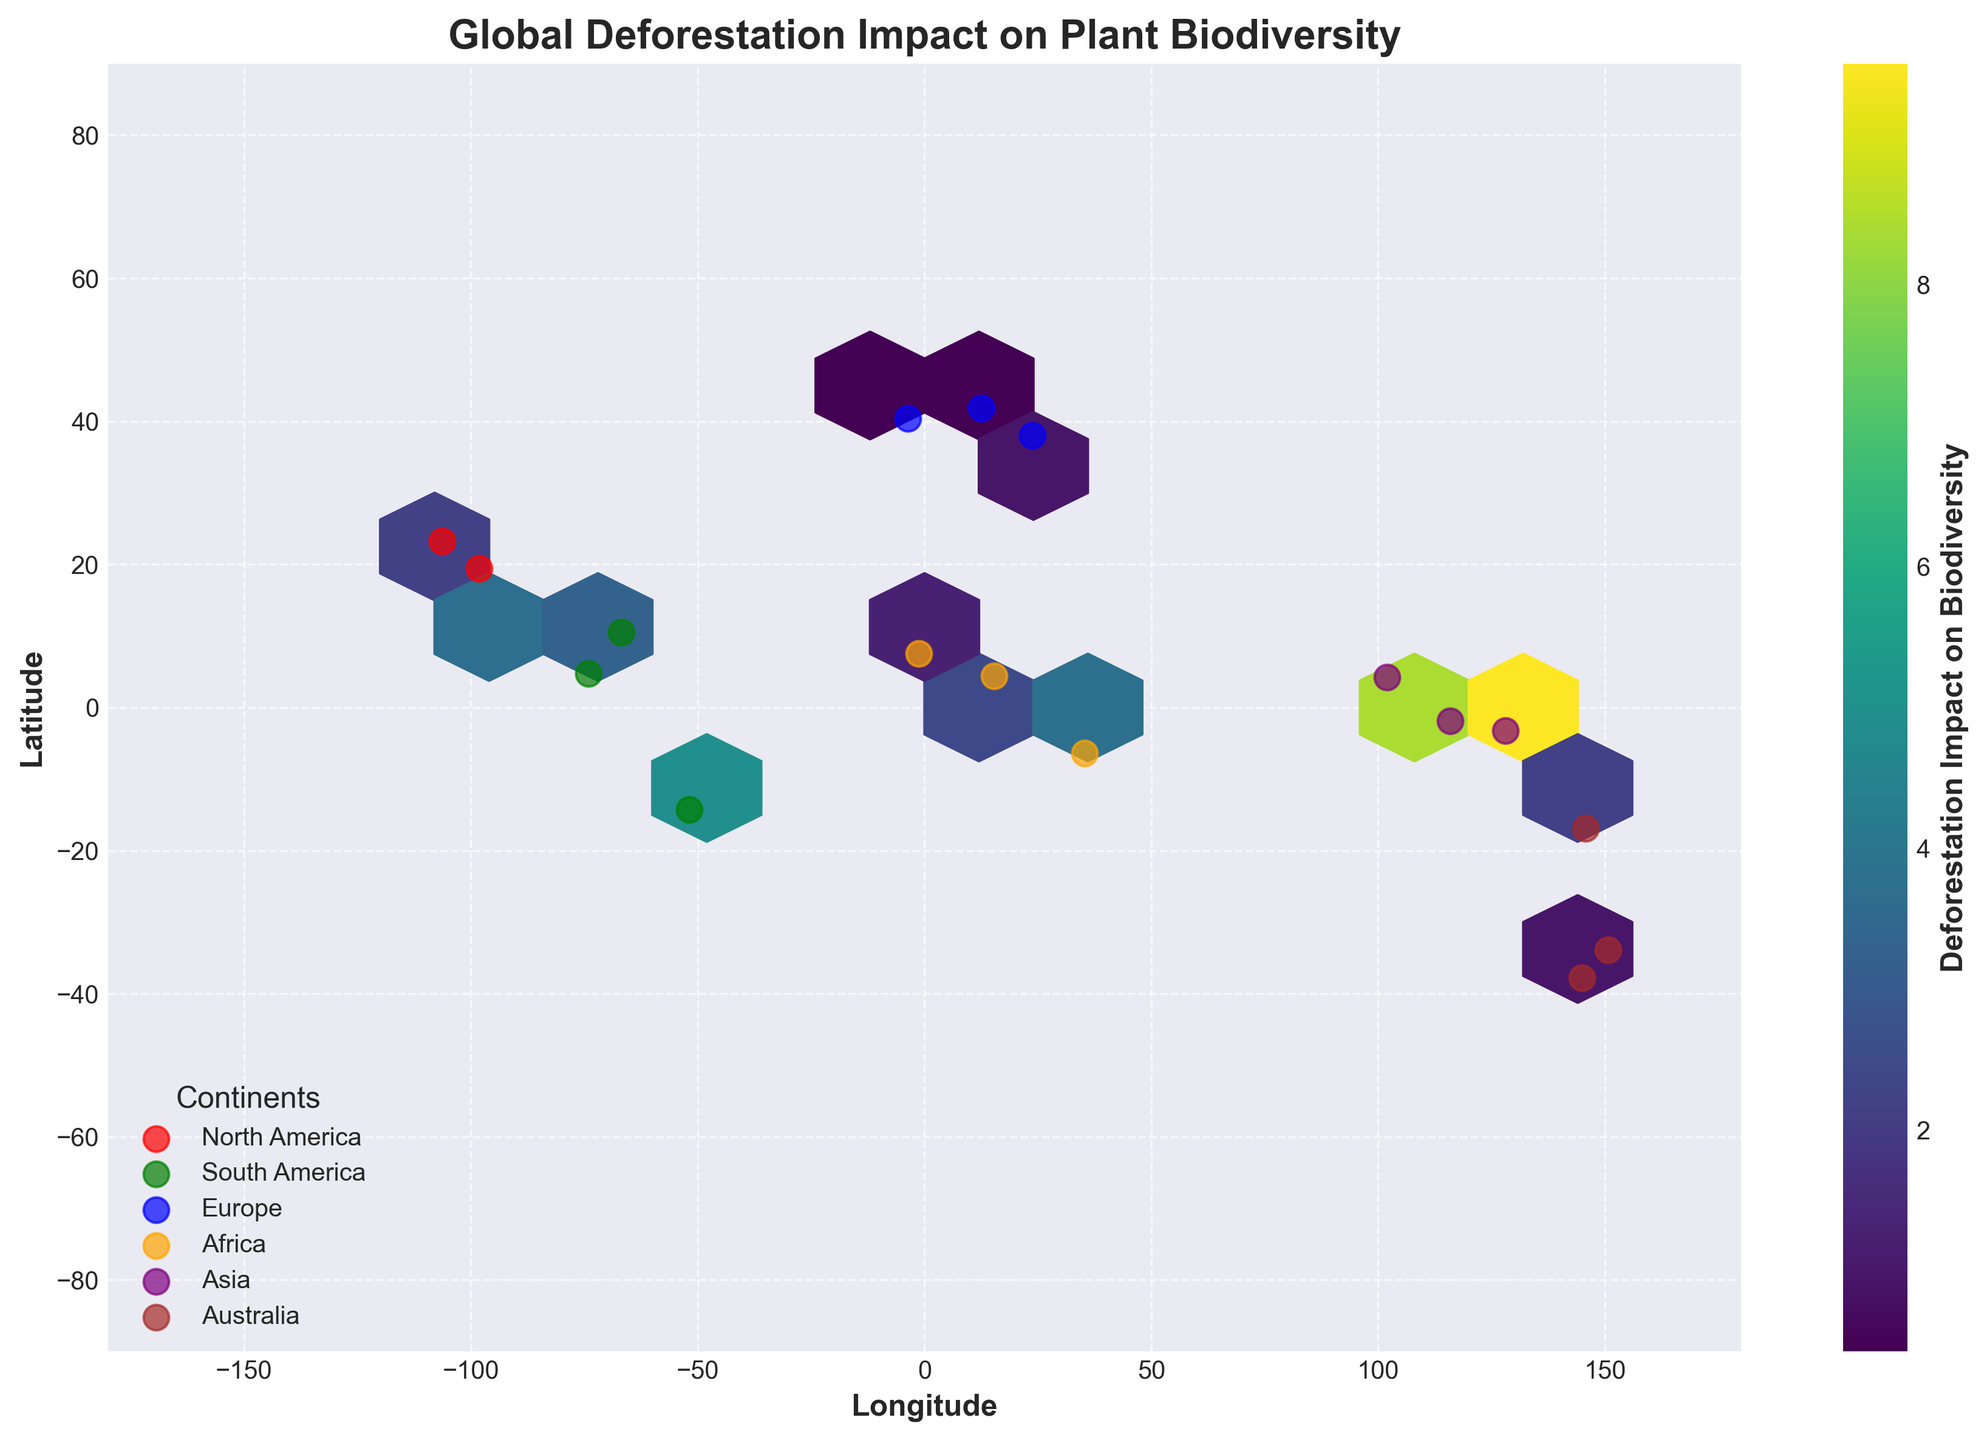What is the title of the figure? Look at the top of the figure where the title is located, it is usually found above the plot. The title summarizes the focus of the figure.
Answer: Global Deforestation Impact on Plant Biodiversity How many continents are represented in the plot? Identify the number of different labels in the legend, each representing a unique continent.
Answer: Six What color represents data points from Africa? Check the legend at the bottom of the plot, which matches each color to a continent.
Answer: Orange Which continent shows the highest concentration of deforestation impact on biodiversity? Observe the hexbin areas with the highest color intensity, which indicate higher combined values of deforestation rates and plant biodiversity indices. Then, refer to the colors and symbols specific to each continent from the legend.
Answer: Asia What is the latitude range covered in the plot? Look at the y-axis, which represents the latitude, and note the minimum and maximum values listed.
Answer: -90 to 90 How does deforestation impact plant biodiversity in South America compared to Africa? Compare the color intensities within the hexbin cells that represent South America and Africa. The more intense the color, the higher the impact.
Answer: South America shows generally higher impact cells indicated by more intense colors compared to Africa Which continent has the lowest individual impact values in the scatter plot, based on the hexbin plot colors? Find the scatter plot colors associated with continents (labels in the legend) and observe where these have the least impact colors (lighter shades).
Answer: Europe What is the approximate longitude of the highest deforestation impact zone in Asia? Identify the region in the hexbin plot where the color is the most intense for Asia. Then, find the corresponding value along the x-axis (longitude).
Answer: 100 to 130 degrees East Looking at the plot, can you determine which latitude in Central America experiences significant deforestation impact? Look for the position of Central America data points (in green) and determine the most significant latitude based on color intensity and location on the y-axis.
Answer: Approximately 10 degrees North Which continent has the widest range of longitudes represented in the figure? Examine the spread of data points for each continent along the x-axis (longitude). The continent with the widest horizontal distribution has the broadest longitude range.
Answer: Asia 